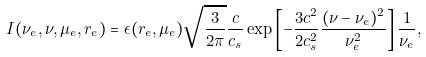<formula> <loc_0><loc_0><loc_500><loc_500>I ( \nu _ { e } , \nu , \mu _ { e } , r _ { e } ) = \epsilon ( r _ { e } , \mu _ { e } ) \sqrt { \frac { 3 } { 2 \pi } } \frac { c } { c _ { s } } \exp \left [ - \frac { 3 c ^ { 2 } } { 2 c _ { s } ^ { 2 } } \frac { ( \nu - \nu _ { e } ) ^ { 2 } } { \nu _ { e } ^ { 2 } } \right ] \frac { 1 } { \nu _ { e } } ,</formula> 